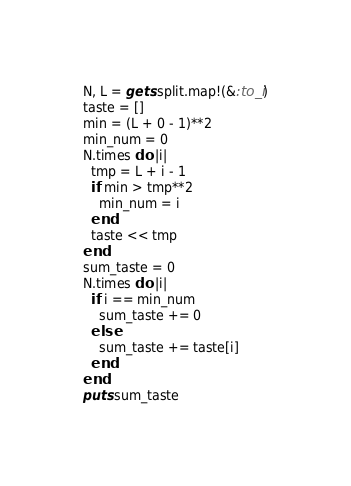Convert code to text. <code><loc_0><loc_0><loc_500><loc_500><_Ruby_>N, L = gets.split.map!(&:to_i)
taste = []
min = (L + 0 - 1)**2
min_num = 0
N.times do |i|
  tmp = L + i - 1
  if min > tmp**2
    min_num = i
  end
  taste << tmp
end
sum_taste = 0
N.times do |i|
  if i == min_num
    sum_taste += 0
  else
    sum_taste += taste[i]
  end
end
puts sum_taste</code> 